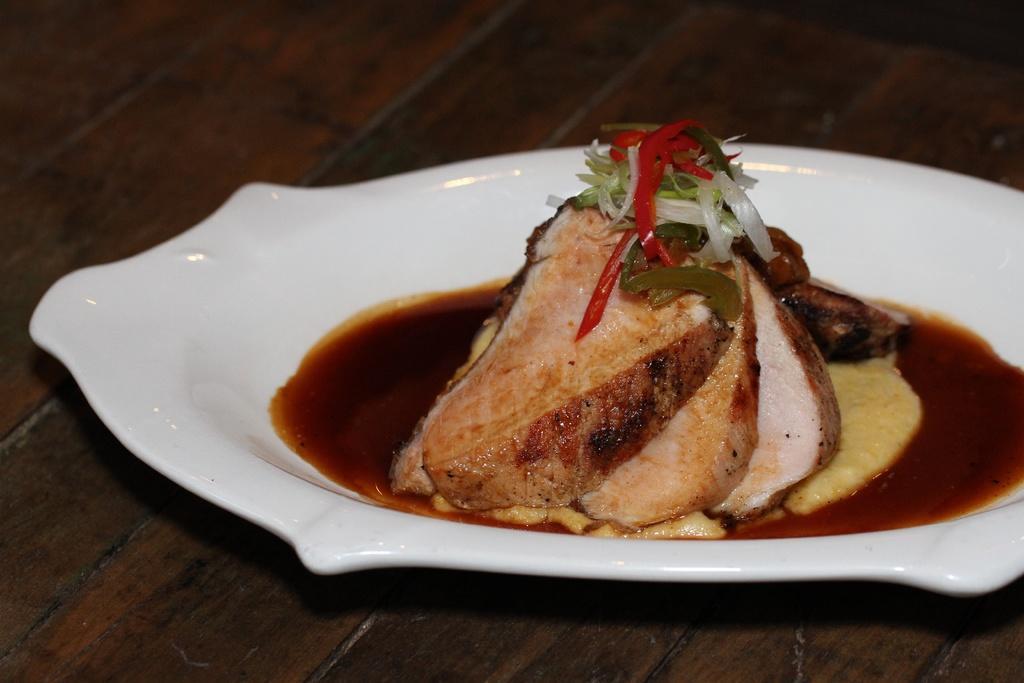Describe this image in one or two sentences. In this picture we can see a plate, there is some food and sauce present in the plate, at the bottom there is a wooden surface. 